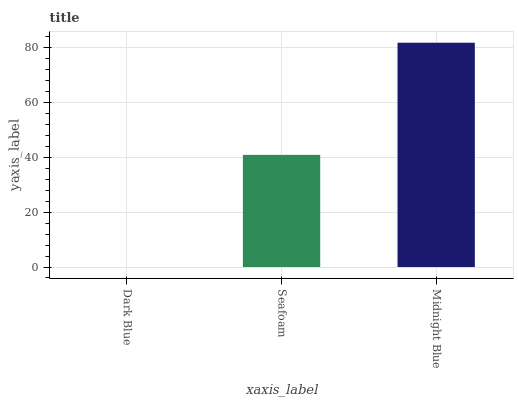Is Seafoam the minimum?
Answer yes or no. No. Is Seafoam the maximum?
Answer yes or no. No. Is Seafoam greater than Dark Blue?
Answer yes or no. Yes. Is Dark Blue less than Seafoam?
Answer yes or no. Yes. Is Dark Blue greater than Seafoam?
Answer yes or no. No. Is Seafoam less than Dark Blue?
Answer yes or no. No. Is Seafoam the high median?
Answer yes or no. Yes. Is Seafoam the low median?
Answer yes or no. Yes. Is Midnight Blue the high median?
Answer yes or no. No. Is Midnight Blue the low median?
Answer yes or no. No. 